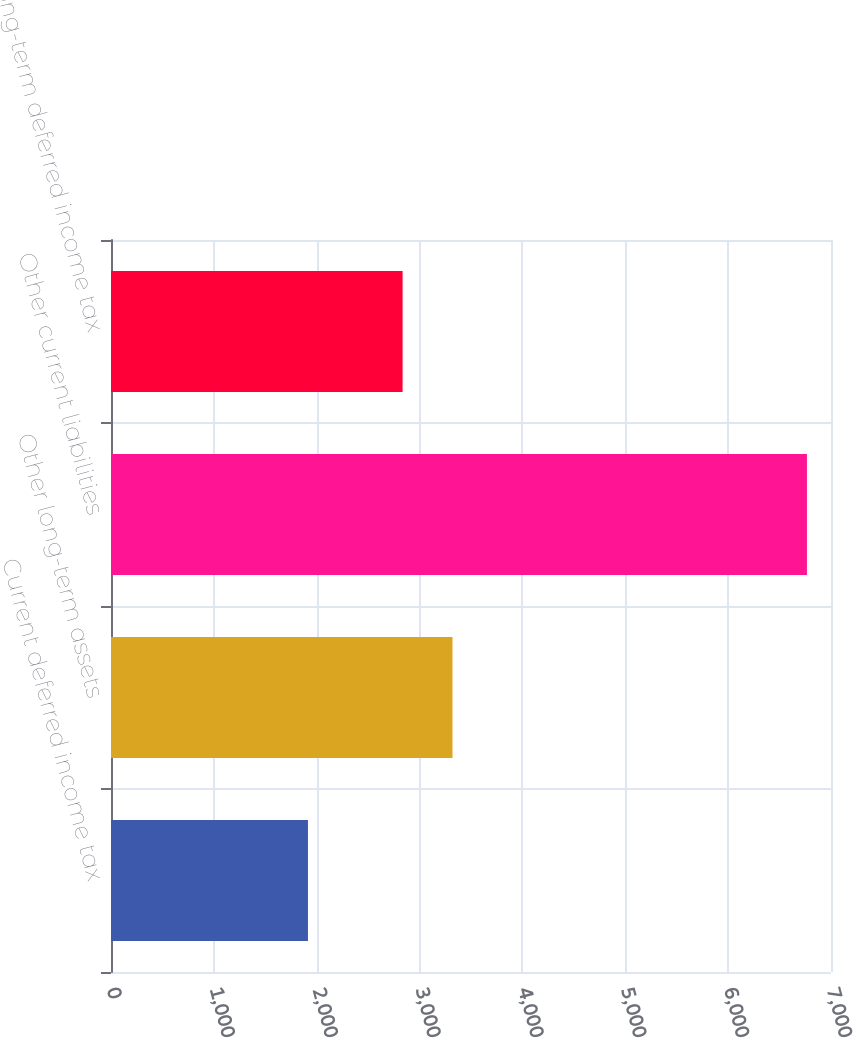Convert chart to OTSL. <chart><loc_0><loc_0><loc_500><loc_500><bar_chart><fcel>Current deferred income tax<fcel>Other long-term assets<fcel>Other current liabilities<fcel>Long-term deferred income tax<nl><fcel>1915<fcel>3320.1<fcel>6766<fcel>2835<nl></chart> 